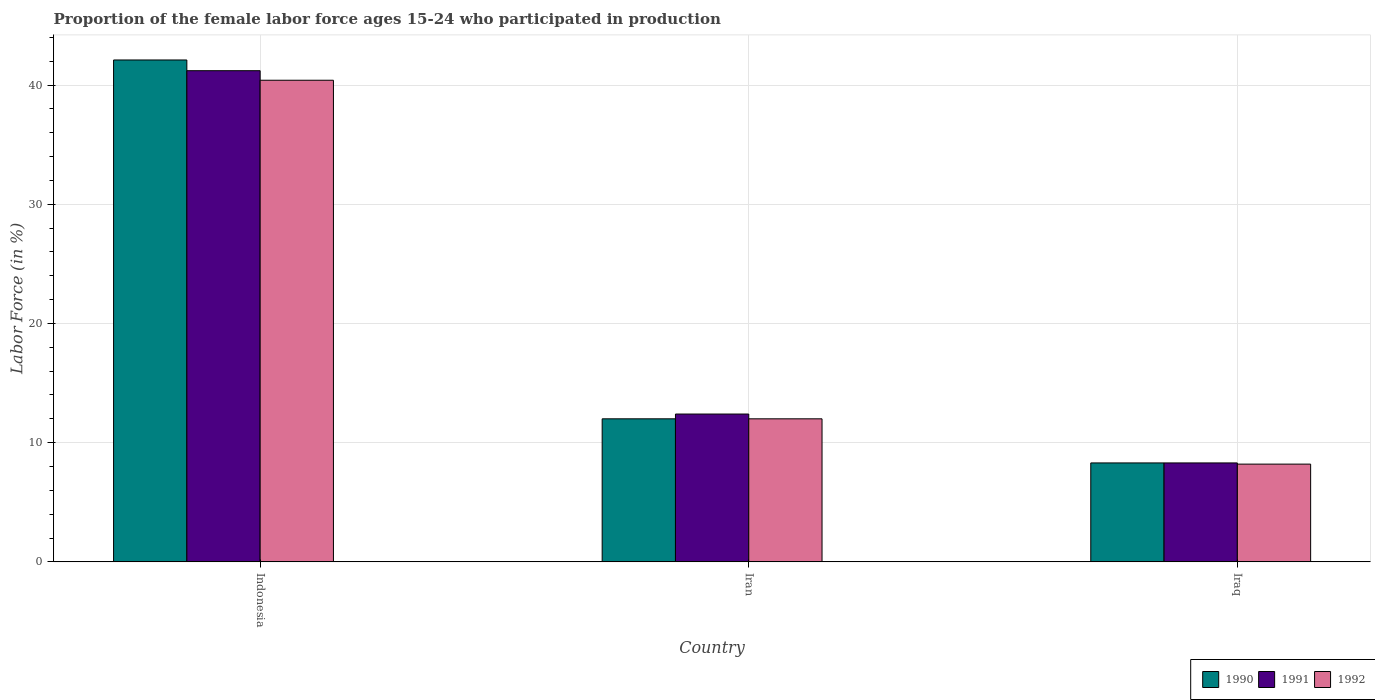How many different coloured bars are there?
Provide a short and direct response. 3. Are the number of bars per tick equal to the number of legend labels?
Offer a very short reply. Yes. Are the number of bars on each tick of the X-axis equal?
Provide a succinct answer. Yes. How many bars are there on the 2nd tick from the right?
Make the answer very short. 3. What is the label of the 1st group of bars from the left?
Provide a succinct answer. Indonesia. In how many cases, is the number of bars for a given country not equal to the number of legend labels?
Your response must be concise. 0. What is the proportion of the female labor force who participated in production in 1990 in Indonesia?
Offer a terse response. 42.1. Across all countries, what is the maximum proportion of the female labor force who participated in production in 1991?
Keep it short and to the point. 41.2. Across all countries, what is the minimum proportion of the female labor force who participated in production in 1991?
Provide a short and direct response. 8.3. In which country was the proportion of the female labor force who participated in production in 1991 maximum?
Make the answer very short. Indonesia. In which country was the proportion of the female labor force who participated in production in 1991 minimum?
Ensure brevity in your answer.  Iraq. What is the total proportion of the female labor force who participated in production in 1991 in the graph?
Your answer should be compact. 61.9. What is the difference between the proportion of the female labor force who participated in production in 1991 in Iran and that in Iraq?
Your answer should be compact. 4.1. What is the difference between the proportion of the female labor force who participated in production in 1992 in Iran and the proportion of the female labor force who participated in production in 1991 in Indonesia?
Offer a very short reply. -29.2. What is the average proportion of the female labor force who participated in production in 1991 per country?
Your answer should be very brief. 20.63. What is the difference between the proportion of the female labor force who participated in production of/in 1991 and proportion of the female labor force who participated in production of/in 1990 in Iraq?
Offer a terse response. 0. What is the ratio of the proportion of the female labor force who participated in production in 1992 in Iran to that in Iraq?
Your answer should be very brief. 1.46. What is the difference between the highest and the second highest proportion of the female labor force who participated in production in 1991?
Your answer should be compact. -32.9. What is the difference between the highest and the lowest proportion of the female labor force who participated in production in 1992?
Give a very brief answer. 32.2. In how many countries, is the proportion of the female labor force who participated in production in 1991 greater than the average proportion of the female labor force who participated in production in 1991 taken over all countries?
Make the answer very short. 1. Is the sum of the proportion of the female labor force who participated in production in 1992 in Indonesia and Iran greater than the maximum proportion of the female labor force who participated in production in 1991 across all countries?
Give a very brief answer. Yes. How many bars are there?
Offer a very short reply. 9. What is the difference between two consecutive major ticks on the Y-axis?
Keep it short and to the point. 10. Does the graph contain any zero values?
Your response must be concise. No. How many legend labels are there?
Offer a very short reply. 3. How are the legend labels stacked?
Ensure brevity in your answer.  Horizontal. What is the title of the graph?
Keep it short and to the point. Proportion of the female labor force ages 15-24 who participated in production. Does "2015" appear as one of the legend labels in the graph?
Ensure brevity in your answer.  No. What is the label or title of the X-axis?
Offer a terse response. Country. What is the Labor Force (in %) in 1990 in Indonesia?
Your answer should be compact. 42.1. What is the Labor Force (in %) in 1991 in Indonesia?
Make the answer very short. 41.2. What is the Labor Force (in %) of 1992 in Indonesia?
Your answer should be very brief. 40.4. What is the Labor Force (in %) of 1990 in Iran?
Provide a short and direct response. 12. What is the Labor Force (in %) of 1991 in Iran?
Offer a very short reply. 12.4. What is the Labor Force (in %) in 1992 in Iran?
Ensure brevity in your answer.  12. What is the Labor Force (in %) of 1990 in Iraq?
Provide a succinct answer. 8.3. What is the Labor Force (in %) in 1991 in Iraq?
Ensure brevity in your answer.  8.3. What is the Labor Force (in %) in 1992 in Iraq?
Keep it short and to the point. 8.2. Across all countries, what is the maximum Labor Force (in %) in 1990?
Your answer should be very brief. 42.1. Across all countries, what is the maximum Labor Force (in %) in 1991?
Offer a very short reply. 41.2. Across all countries, what is the maximum Labor Force (in %) of 1992?
Make the answer very short. 40.4. Across all countries, what is the minimum Labor Force (in %) of 1990?
Give a very brief answer. 8.3. Across all countries, what is the minimum Labor Force (in %) of 1991?
Make the answer very short. 8.3. Across all countries, what is the minimum Labor Force (in %) of 1992?
Provide a short and direct response. 8.2. What is the total Labor Force (in %) in 1990 in the graph?
Offer a very short reply. 62.4. What is the total Labor Force (in %) in 1991 in the graph?
Offer a very short reply. 61.9. What is the total Labor Force (in %) of 1992 in the graph?
Give a very brief answer. 60.6. What is the difference between the Labor Force (in %) in 1990 in Indonesia and that in Iran?
Provide a short and direct response. 30.1. What is the difference between the Labor Force (in %) of 1991 in Indonesia and that in Iran?
Your answer should be compact. 28.8. What is the difference between the Labor Force (in %) of 1992 in Indonesia and that in Iran?
Your answer should be very brief. 28.4. What is the difference between the Labor Force (in %) in 1990 in Indonesia and that in Iraq?
Offer a very short reply. 33.8. What is the difference between the Labor Force (in %) of 1991 in Indonesia and that in Iraq?
Keep it short and to the point. 32.9. What is the difference between the Labor Force (in %) in 1992 in Indonesia and that in Iraq?
Provide a succinct answer. 32.2. What is the difference between the Labor Force (in %) in 1992 in Iran and that in Iraq?
Provide a short and direct response. 3.8. What is the difference between the Labor Force (in %) of 1990 in Indonesia and the Labor Force (in %) of 1991 in Iran?
Give a very brief answer. 29.7. What is the difference between the Labor Force (in %) in 1990 in Indonesia and the Labor Force (in %) in 1992 in Iran?
Offer a very short reply. 30.1. What is the difference between the Labor Force (in %) in 1991 in Indonesia and the Labor Force (in %) in 1992 in Iran?
Offer a terse response. 29.2. What is the difference between the Labor Force (in %) of 1990 in Indonesia and the Labor Force (in %) of 1991 in Iraq?
Your answer should be compact. 33.8. What is the difference between the Labor Force (in %) in 1990 in Indonesia and the Labor Force (in %) in 1992 in Iraq?
Make the answer very short. 33.9. What is the difference between the Labor Force (in %) of 1991 in Indonesia and the Labor Force (in %) of 1992 in Iraq?
Give a very brief answer. 33. What is the difference between the Labor Force (in %) in 1991 in Iran and the Labor Force (in %) in 1992 in Iraq?
Your answer should be compact. 4.2. What is the average Labor Force (in %) in 1990 per country?
Your answer should be very brief. 20.8. What is the average Labor Force (in %) in 1991 per country?
Your answer should be compact. 20.63. What is the average Labor Force (in %) of 1992 per country?
Your answer should be very brief. 20.2. What is the difference between the Labor Force (in %) in 1991 and Labor Force (in %) in 1992 in Indonesia?
Keep it short and to the point. 0.8. What is the difference between the Labor Force (in %) in 1990 and Labor Force (in %) in 1992 in Iraq?
Ensure brevity in your answer.  0.1. What is the difference between the Labor Force (in %) of 1991 and Labor Force (in %) of 1992 in Iraq?
Your response must be concise. 0.1. What is the ratio of the Labor Force (in %) of 1990 in Indonesia to that in Iran?
Offer a terse response. 3.51. What is the ratio of the Labor Force (in %) in 1991 in Indonesia to that in Iran?
Keep it short and to the point. 3.32. What is the ratio of the Labor Force (in %) in 1992 in Indonesia to that in Iran?
Make the answer very short. 3.37. What is the ratio of the Labor Force (in %) of 1990 in Indonesia to that in Iraq?
Offer a very short reply. 5.07. What is the ratio of the Labor Force (in %) in 1991 in Indonesia to that in Iraq?
Offer a terse response. 4.96. What is the ratio of the Labor Force (in %) of 1992 in Indonesia to that in Iraq?
Make the answer very short. 4.93. What is the ratio of the Labor Force (in %) in 1990 in Iran to that in Iraq?
Offer a terse response. 1.45. What is the ratio of the Labor Force (in %) of 1991 in Iran to that in Iraq?
Ensure brevity in your answer.  1.49. What is the ratio of the Labor Force (in %) in 1992 in Iran to that in Iraq?
Make the answer very short. 1.46. What is the difference between the highest and the second highest Labor Force (in %) in 1990?
Your response must be concise. 30.1. What is the difference between the highest and the second highest Labor Force (in %) in 1991?
Your answer should be very brief. 28.8. What is the difference between the highest and the second highest Labor Force (in %) in 1992?
Provide a succinct answer. 28.4. What is the difference between the highest and the lowest Labor Force (in %) of 1990?
Your response must be concise. 33.8. What is the difference between the highest and the lowest Labor Force (in %) in 1991?
Keep it short and to the point. 32.9. What is the difference between the highest and the lowest Labor Force (in %) of 1992?
Offer a terse response. 32.2. 